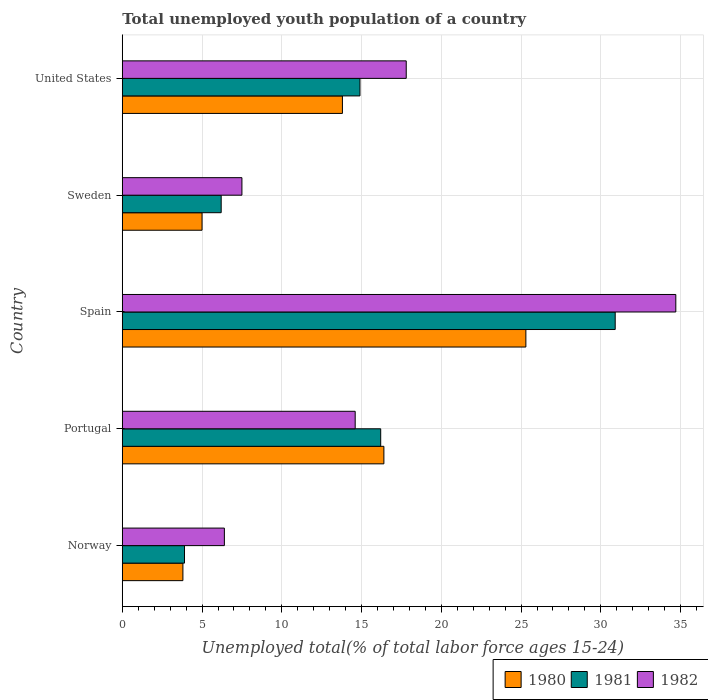How many bars are there on the 4th tick from the top?
Provide a short and direct response. 3. How many bars are there on the 1st tick from the bottom?
Keep it short and to the point. 3. What is the label of the 1st group of bars from the top?
Offer a very short reply. United States. In how many cases, is the number of bars for a given country not equal to the number of legend labels?
Your answer should be very brief. 0. What is the percentage of total unemployed youth population of a country in 1980 in Portugal?
Provide a succinct answer. 16.4. Across all countries, what is the maximum percentage of total unemployed youth population of a country in 1980?
Offer a terse response. 25.3. Across all countries, what is the minimum percentage of total unemployed youth population of a country in 1982?
Ensure brevity in your answer.  6.4. What is the total percentage of total unemployed youth population of a country in 1980 in the graph?
Your answer should be very brief. 64.3. What is the difference between the percentage of total unemployed youth population of a country in 1981 in Norway and that in Portugal?
Provide a succinct answer. -12.3. What is the difference between the percentage of total unemployed youth population of a country in 1982 in Portugal and the percentage of total unemployed youth population of a country in 1980 in Sweden?
Your response must be concise. 9.6. What is the average percentage of total unemployed youth population of a country in 1980 per country?
Offer a very short reply. 12.86. What is the difference between the percentage of total unemployed youth population of a country in 1982 and percentage of total unemployed youth population of a country in 1980 in Portugal?
Your answer should be very brief. -1.8. What is the ratio of the percentage of total unemployed youth population of a country in 1981 in Portugal to that in Sweden?
Your response must be concise. 2.61. What is the difference between the highest and the second highest percentage of total unemployed youth population of a country in 1981?
Your answer should be very brief. 14.7. What is the difference between the highest and the lowest percentage of total unemployed youth population of a country in 1982?
Your answer should be compact. 28.3. In how many countries, is the percentage of total unemployed youth population of a country in 1980 greater than the average percentage of total unemployed youth population of a country in 1980 taken over all countries?
Offer a very short reply. 3. Is the sum of the percentage of total unemployed youth population of a country in 1982 in Norway and Spain greater than the maximum percentage of total unemployed youth population of a country in 1981 across all countries?
Ensure brevity in your answer.  Yes. How many bars are there?
Provide a short and direct response. 15. Are the values on the major ticks of X-axis written in scientific E-notation?
Your answer should be very brief. No. Does the graph contain grids?
Keep it short and to the point. Yes. Where does the legend appear in the graph?
Provide a short and direct response. Bottom right. How are the legend labels stacked?
Your response must be concise. Horizontal. What is the title of the graph?
Offer a terse response. Total unemployed youth population of a country. What is the label or title of the X-axis?
Keep it short and to the point. Unemployed total(% of total labor force ages 15-24). What is the Unemployed total(% of total labor force ages 15-24) of 1980 in Norway?
Offer a terse response. 3.8. What is the Unemployed total(% of total labor force ages 15-24) of 1981 in Norway?
Offer a very short reply. 3.9. What is the Unemployed total(% of total labor force ages 15-24) in 1982 in Norway?
Give a very brief answer. 6.4. What is the Unemployed total(% of total labor force ages 15-24) of 1980 in Portugal?
Offer a terse response. 16.4. What is the Unemployed total(% of total labor force ages 15-24) in 1981 in Portugal?
Ensure brevity in your answer.  16.2. What is the Unemployed total(% of total labor force ages 15-24) of 1982 in Portugal?
Your response must be concise. 14.6. What is the Unemployed total(% of total labor force ages 15-24) in 1980 in Spain?
Ensure brevity in your answer.  25.3. What is the Unemployed total(% of total labor force ages 15-24) in 1981 in Spain?
Provide a succinct answer. 30.9. What is the Unemployed total(% of total labor force ages 15-24) in 1982 in Spain?
Provide a succinct answer. 34.7. What is the Unemployed total(% of total labor force ages 15-24) in 1980 in Sweden?
Offer a very short reply. 5. What is the Unemployed total(% of total labor force ages 15-24) in 1981 in Sweden?
Offer a very short reply. 6.2. What is the Unemployed total(% of total labor force ages 15-24) in 1982 in Sweden?
Provide a short and direct response. 7.5. What is the Unemployed total(% of total labor force ages 15-24) of 1980 in United States?
Give a very brief answer. 13.8. What is the Unemployed total(% of total labor force ages 15-24) in 1981 in United States?
Your response must be concise. 14.9. What is the Unemployed total(% of total labor force ages 15-24) in 1982 in United States?
Your answer should be compact. 17.8. Across all countries, what is the maximum Unemployed total(% of total labor force ages 15-24) of 1980?
Your answer should be very brief. 25.3. Across all countries, what is the maximum Unemployed total(% of total labor force ages 15-24) of 1981?
Your response must be concise. 30.9. Across all countries, what is the maximum Unemployed total(% of total labor force ages 15-24) of 1982?
Provide a short and direct response. 34.7. Across all countries, what is the minimum Unemployed total(% of total labor force ages 15-24) of 1980?
Your answer should be compact. 3.8. Across all countries, what is the minimum Unemployed total(% of total labor force ages 15-24) of 1981?
Keep it short and to the point. 3.9. Across all countries, what is the minimum Unemployed total(% of total labor force ages 15-24) in 1982?
Offer a terse response. 6.4. What is the total Unemployed total(% of total labor force ages 15-24) in 1980 in the graph?
Offer a very short reply. 64.3. What is the total Unemployed total(% of total labor force ages 15-24) of 1981 in the graph?
Make the answer very short. 72.1. What is the total Unemployed total(% of total labor force ages 15-24) of 1982 in the graph?
Make the answer very short. 81. What is the difference between the Unemployed total(% of total labor force ages 15-24) of 1982 in Norway and that in Portugal?
Offer a terse response. -8.2. What is the difference between the Unemployed total(% of total labor force ages 15-24) of 1980 in Norway and that in Spain?
Keep it short and to the point. -21.5. What is the difference between the Unemployed total(% of total labor force ages 15-24) of 1982 in Norway and that in Spain?
Provide a short and direct response. -28.3. What is the difference between the Unemployed total(% of total labor force ages 15-24) in 1980 in Norway and that in Sweden?
Make the answer very short. -1.2. What is the difference between the Unemployed total(% of total labor force ages 15-24) in 1982 in Norway and that in Sweden?
Give a very brief answer. -1.1. What is the difference between the Unemployed total(% of total labor force ages 15-24) of 1980 in Norway and that in United States?
Offer a terse response. -10. What is the difference between the Unemployed total(% of total labor force ages 15-24) of 1981 in Portugal and that in Spain?
Your answer should be very brief. -14.7. What is the difference between the Unemployed total(% of total labor force ages 15-24) of 1982 in Portugal and that in Spain?
Your answer should be very brief. -20.1. What is the difference between the Unemployed total(% of total labor force ages 15-24) of 1980 in Portugal and that in Sweden?
Make the answer very short. 11.4. What is the difference between the Unemployed total(% of total labor force ages 15-24) in 1981 in Portugal and that in United States?
Give a very brief answer. 1.3. What is the difference between the Unemployed total(% of total labor force ages 15-24) in 1980 in Spain and that in Sweden?
Your response must be concise. 20.3. What is the difference between the Unemployed total(% of total labor force ages 15-24) in 1981 in Spain and that in Sweden?
Offer a very short reply. 24.7. What is the difference between the Unemployed total(% of total labor force ages 15-24) of 1982 in Spain and that in Sweden?
Provide a succinct answer. 27.2. What is the difference between the Unemployed total(% of total labor force ages 15-24) of 1981 in Sweden and that in United States?
Your answer should be very brief. -8.7. What is the difference between the Unemployed total(% of total labor force ages 15-24) of 1982 in Sweden and that in United States?
Keep it short and to the point. -10.3. What is the difference between the Unemployed total(% of total labor force ages 15-24) of 1980 in Norway and the Unemployed total(% of total labor force ages 15-24) of 1981 in Portugal?
Your answer should be very brief. -12.4. What is the difference between the Unemployed total(% of total labor force ages 15-24) of 1981 in Norway and the Unemployed total(% of total labor force ages 15-24) of 1982 in Portugal?
Provide a succinct answer. -10.7. What is the difference between the Unemployed total(% of total labor force ages 15-24) in 1980 in Norway and the Unemployed total(% of total labor force ages 15-24) in 1981 in Spain?
Your answer should be very brief. -27.1. What is the difference between the Unemployed total(% of total labor force ages 15-24) of 1980 in Norway and the Unemployed total(% of total labor force ages 15-24) of 1982 in Spain?
Give a very brief answer. -30.9. What is the difference between the Unemployed total(% of total labor force ages 15-24) of 1981 in Norway and the Unemployed total(% of total labor force ages 15-24) of 1982 in Spain?
Your answer should be very brief. -30.8. What is the difference between the Unemployed total(% of total labor force ages 15-24) in 1980 in Norway and the Unemployed total(% of total labor force ages 15-24) in 1982 in Sweden?
Offer a terse response. -3.7. What is the difference between the Unemployed total(% of total labor force ages 15-24) in 1981 in Norway and the Unemployed total(% of total labor force ages 15-24) in 1982 in Sweden?
Provide a short and direct response. -3.6. What is the difference between the Unemployed total(% of total labor force ages 15-24) in 1981 in Norway and the Unemployed total(% of total labor force ages 15-24) in 1982 in United States?
Your answer should be compact. -13.9. What is the difference between the Unemployed total(% of total labor force ages 15-24) of 1980 in Portugal and the Unemployed total(% of total labor force ages 15-24) of 1981 in Spain?
Offer a terse response. -14.5. What is the difference between the Unemployed total(% of total labor force ages 15-24) of 1980 in Portugal and the Unemployed total(% of total labor force ages 15-24) of 1982 in Spain?
Offer a terse response. -18.3. What is the difference between the Unemployed total(% of total labor force ages 15-24) in 1981 in Portugal and the Unemployed total(% of total labor force ages 15-24) in 1982 in Spain?
Keep it short and to the point. -18.5. What is the difference between the Unemployed total(% of total labor force ages 15-24) of 1981 in Portugal and the Unemployed total(% of total labor force ages 15-24) of 1982 in United States?
Provide a succinct answer. -1.6. What is the difference between the Unemployed total(% of total labor force ages 15-24) in 1980 in Spain and the Unemployed total(% of total labor force ages 15-24) in 1982 in Sweden?
Offer a terse response. 17.8. What is the difference between the Unemployed total(% of total labor force ages 15-24) of 1981 in Spain and the Unemployed total(% of total labor force ages 15-24) of 1982 in Sweden?
Keep it short and to the point. 23.4. What is the difference between the Unemployed total(% of total labor force ages 15-24) of 1980 in Spain and the Unemployed total(% of total labor force ages 15-24) of 1982 in United States?
Provide a succinct answer. 7.5. What is the difference between the Unemployed total(% of total labor force ages 15-24) of 1980 in Sweden and the Unemployed total(% of total labor force ages 15-24) of 1982 in United States?
Your answer should be very brief. -12.8. What is the difference between the Unemployed total(% of total labor force ages 15-24) of 1981 in Sweden and the Unemployed total(% of total labor force ages 15-24) of 1982 in United States?
Keep it short and to the point. -11.6. What is the average Unemployed total(% of total labor force ages 15-24) in 1980 per country?
Make the answer very short. 12.86. What is the average Unemployed total(% of total labor force ages 15-24) of 1981 per country?
Ensure brevity in your answer.  14.42. What is the average Unemployed total(% of total labor force ages 15-24) in 1982 per country?
Provide a succinct answer. 16.2. What is the difference between the Unemployed total(% of total labor force ages 15-24) of 1980 and Unemployed total(% of total labor force ages 15-24) of 1981 in Norway?
Keep it short and to the point. -0.1. What is the difference between the Unemployed total(% of total labor force ages 15-24) of 1980 and Unemployed total(% of total labor force ages 15-24) of 1982 in Norway?
Your answer should be compact. -2.6. What is the difference between the Unemployed total(% of total labor force ages 15-24) in 1980 and Unemployed total(% of total labor force ages 15-24) in 1981 in Portugal?
Offer a terse response. 0.2. What is the difference between the Unemployed total(% of total labor force ages 15-24) of 1980 and Unemployed total(% of total labor force ages 15-24) of 1982 in Spain?
Your answer should be compact. -9.4. What is the difference between the Unemployed total(% of total labor force ages 15-24) in 1980 and Unemployed total(% of total labor force ages 15-24) in 1981 in Sweden?
Provide a succinct answer. -1.2. What is the difference between the Unemployed total(% of total labor force ages 15-24) in 1980 and Unemployed total(% of total labor force ages 15-24) in 1982 in Sweden?
Give a very brief answer. -2.5. What is the difference between the Unemployed total(% of total labor force ages 15-24) in 1981 and Unemployed total(% of total labor force ages 15-24) in 1982 in Sweden?
Keep it short and to the point. -1.3. What is the difference between the Unemployed total(% of total labor force ages 15-24) of 1980 and Unemployed total(% of total labor force ages 15-24) of 1981 in United States?
Provide a short and direct response. -1.1. What is the ratio of the Unemployed total(% of total labor force ages 15-24) in 1980 in Norway to that in Portugal?
Offer a very short reply. 0.23. What is the ratio of the Unemployed total(% of total labor force ages 15-24) in 1981 in Norway to that in Portugal?
Keep it short and to the point. 0.24. What is the ratio of the Unemployed total(% of total labor force ages 15-24) of 1982 in Norway to that in Portugal?
Keep it short and to the point. 0.44. What is the ratio of the Unemployed total(% of total labor force ages 15-24) of 1980 in Norway to that in Spain?
Make the answer very short. 0.15. What is the ratio of the Unemployed total(% of total labor force ages 15-24) in 1981 in Norway to that in Spain?
Give a very brief answer. 0.13. What is the ratio of the Unemployed total(% of total labor force ages 15-24) of 1982 in Norway to that in Spain?
Provide a succinct answer. 0.18. What is the ratio of the Unemployed total(% of total labor force ages 15-24) of 1980 in Norway to that in Sweden?
Offer a terse response. 0.76. What is the ratio of the Unemployed total(% of total labor force ages 15-24) in 1981 in Norway to that in Sweden?
Offer a very short reply. 0.63. What is the ratio of the Unemployed total(% of total labor force ages 15-24) in 1982 in Norway to that in Sweden?
Ensure brevity in your answer.  0.85. What is the ratio of the Unemployed total(% of total labor force ages 15-24) in 1980 in Norway to that in United States?
Ensure brevity in your answer.  0.28. What is the ratio of the Unemployed total(% of total labor force ages 15-24) of 1981 in Norway to that in United States?
Your response must be concise. 0.26. What is the ratio of the Unemployed total(% of total labor force ages 15-24) of 1982 in Norway to that in United States?
Your answer should be very brief. 0.36. What is the ratio of the Unemployed total(% of total labor force ages 15-24) in 1980 in Portugal to that in Spain?
Keep it short and to the point. 0.65. What is the ratio of the Unemployed total(% of total labor force ages 15-24) in 1981 in Portugal to that in Spain?
Offer a very short reply. 0.52. What is the ratio of the Unemployed total(% of total labor force ages 15-24) of 1982 in Portugal to that in Spain?
Your response must be concise. 0.42. What is the ratio of the Unemployed total(% of total labor force ages 15-24) of 1980 in Portugal to that in Sweden?
Ensure brevity in your answer.  3.28. What is the ratio of the Unemployed total(% of total labor force ages 15-24) in 1981 in Portugal to that in Sweden?
Your answer should be very brief. 2.61. What is the ratio of the Unemployed total(% of total labor force ages 15-24) of 1982 in Portugal to that in Sweden?
Keep it short and to the point. 1.95. What is the ratio of the Unemployed total(% of total labor force ages 15-24) in 1980 in Portugal to that in United States?
Offer a terse response. 1.19. What is the ratio of the Unemployed total(% of total labor force ages 15-24) in 1981 in Portugal to that in United States?
Ensure brevity in your answer.  1.09. What is the ratio of the Unemployed total(% of total labor force ages 15-24) in 1982 in Portugal to that in United States?
Give a very brief answer. 0.82. What is the ratio of the Unemployed total(% of total labor force ages 15-24) in 1980 in Spain to that in Sweden?
Make the answer very short. 5.06. What is the ratio of the Unemployed total(% of total labor force ages 15-24) of 1981 in Spain to that in Sweden?
Ensure brevity in your answer.  4.98. What is the ratio of the Unemployed total(% of total labor force ages 15-24) in 1982 in Spain to that in Sweden?
Your response must be concise. 4.63. What is the ratio of the Unemployed total(% of total labor force ages 15-24) in 1980 in Spain to that in United States?
Your answer should be very brief. 1.83. What is the ratio of the Unemployed total(% of total labor force ages 15-24) in 1981 in Spain to that in United States?
Ensure brevity in your answer.  2.07. What is the ratio of the Unemployed total(% of total labor force ages 15-24) of 1982 in Spain to that in United States?
Offer a very short reply. 1.95. What is the ratio of the Unemployed total(% of total labor force ages 15-24) in 1980 in Sweden to that in United States?
Your answer should be very brief. 0.36. What is the ratio of the Unemployed total(% of total labor force ages 15-24) of 1981 in Sweden to that in United States?
Offer a very short reply. 0.42. What is the ratio of the Unemployed total(% of total labor force ages 15-24) of 1982 in Sweden to that in United States?
Make the answer very short. 0.42. What is the difference between the highest and the second highest Unemployed total(% of total labor force ages 15-24) of 1980?
Your response must be concise. 8.9. What is the difference between the highest and the second highest Unemployed total(% of total labor force ages 15-24) of 1982?
Provide a short and direct response. 16.9. What is the difference between the highest and the lowest Unemployed total(% of total labor force ages 15-24) in 1981?
Provide a short and direct response. 27. What is the difference between the highest and the lowest Unemployed total(% of total labor force ages 15-24) in 1982?
Offer a terse response. 28.3. 